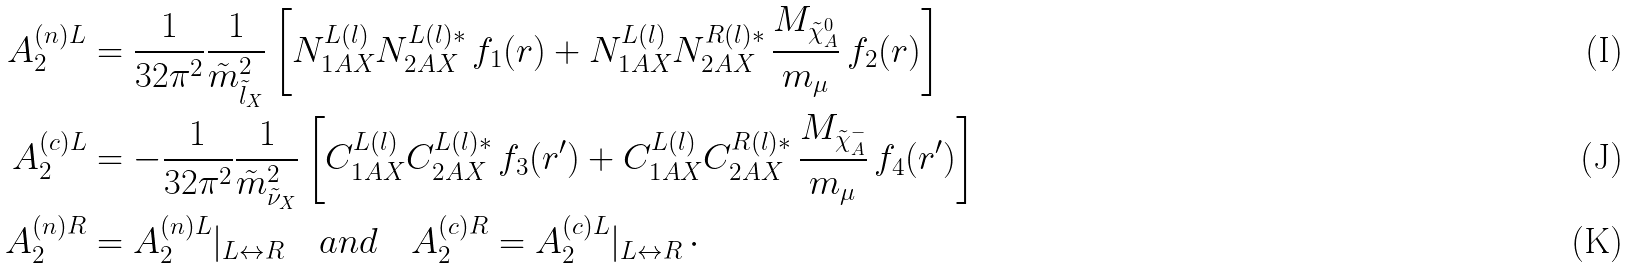<formula> <loc_0><loc_0><loc_500><loc_500>A _ { 2 } ^ { ( n ) L } & = \frac { 1 } { 3 2 \pi ^ { 2 } } \frac { 1 } { \tilde { m } ^ { 2 } _ { \tilde { l } _ { X } } } \left [ N ^ { L ( l ) } _ { 1 A X } N ^ { L ( l ) * } _ { 2 A X } \, f _ { 1 } ( r ) + N ^ { L ( l ) } _ { 1 A X } N ^ { R ( l ) * } _ { 2 A X } \, \frac { M _ { \tilde { \chi } ^ { 0 } _ { A } } } { m _ { \mu } } \, f _ { 2 } ( r ) \right ] \\ A _ { 2 } ^ { ( c ) L } & = - \frac { 1 } { 3 2 \pi ^ { 2 } } \frac { 1 } { \tilde { m } ^ { 2 } _ { \tilde { \nu } _ { X } } } \left [ C ^ { L ( l ) } _ { 1 A X } C ^ { L ( l ) * } _ { 2 A X } \, f _ { 3 } ( r ^ { \prime } ) + C ^ { L ( l ) } _ { 1 A X } C ^ { R ( l ) * } _ { 2 A X } \, \frac { M _ { \tilde { \chi } ^ { - } _ { A } } } { m _ { \mu } } \, f _ { 4 } ( r ^ { \prime } ) \right ] \\ A _ { 2 } ^ { ( n ) R } & = A _ { 2 } ^ { ( n ) L } | _ { L \leftrightarrow R } \quad a n d \quad A _ { 2 } ^ { ( c ) R } = A _ { 2 } ^ { ( c ) L } | _ { L \leftrightarrow R } \, \cdot</formula> 